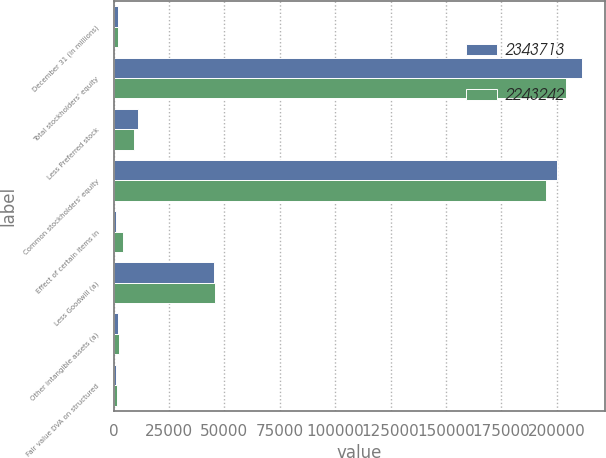Convert chart. <chart><loc_0><loc_0><loc_500><loc_500><stacked_bar_chart><ecel><fcel>December 31 (in millions)<fcel>Total stockholders' equity<fcel>Less Preferred stock<fcel>Common stockholders' equity<fcel>Effect of certain items in<fcel>Less Goodwill (a)<fcel>Other intangible assets (a)<fcel>Fair value DVA on structured<nl><fcel>2.34371e+06<fcel>2013<fcel>211178<fcel>11158<fcel>200020<fcel>1337<fcel>45320<fcel>2012<fcel>1300<nl><fcel>2.24324e+06<fcel>2012<fcel>204069<fcel>9058<fcel>195011<fcel>4198<fcel>45663<fcel>2311<fcel>1577<nl></chart> 